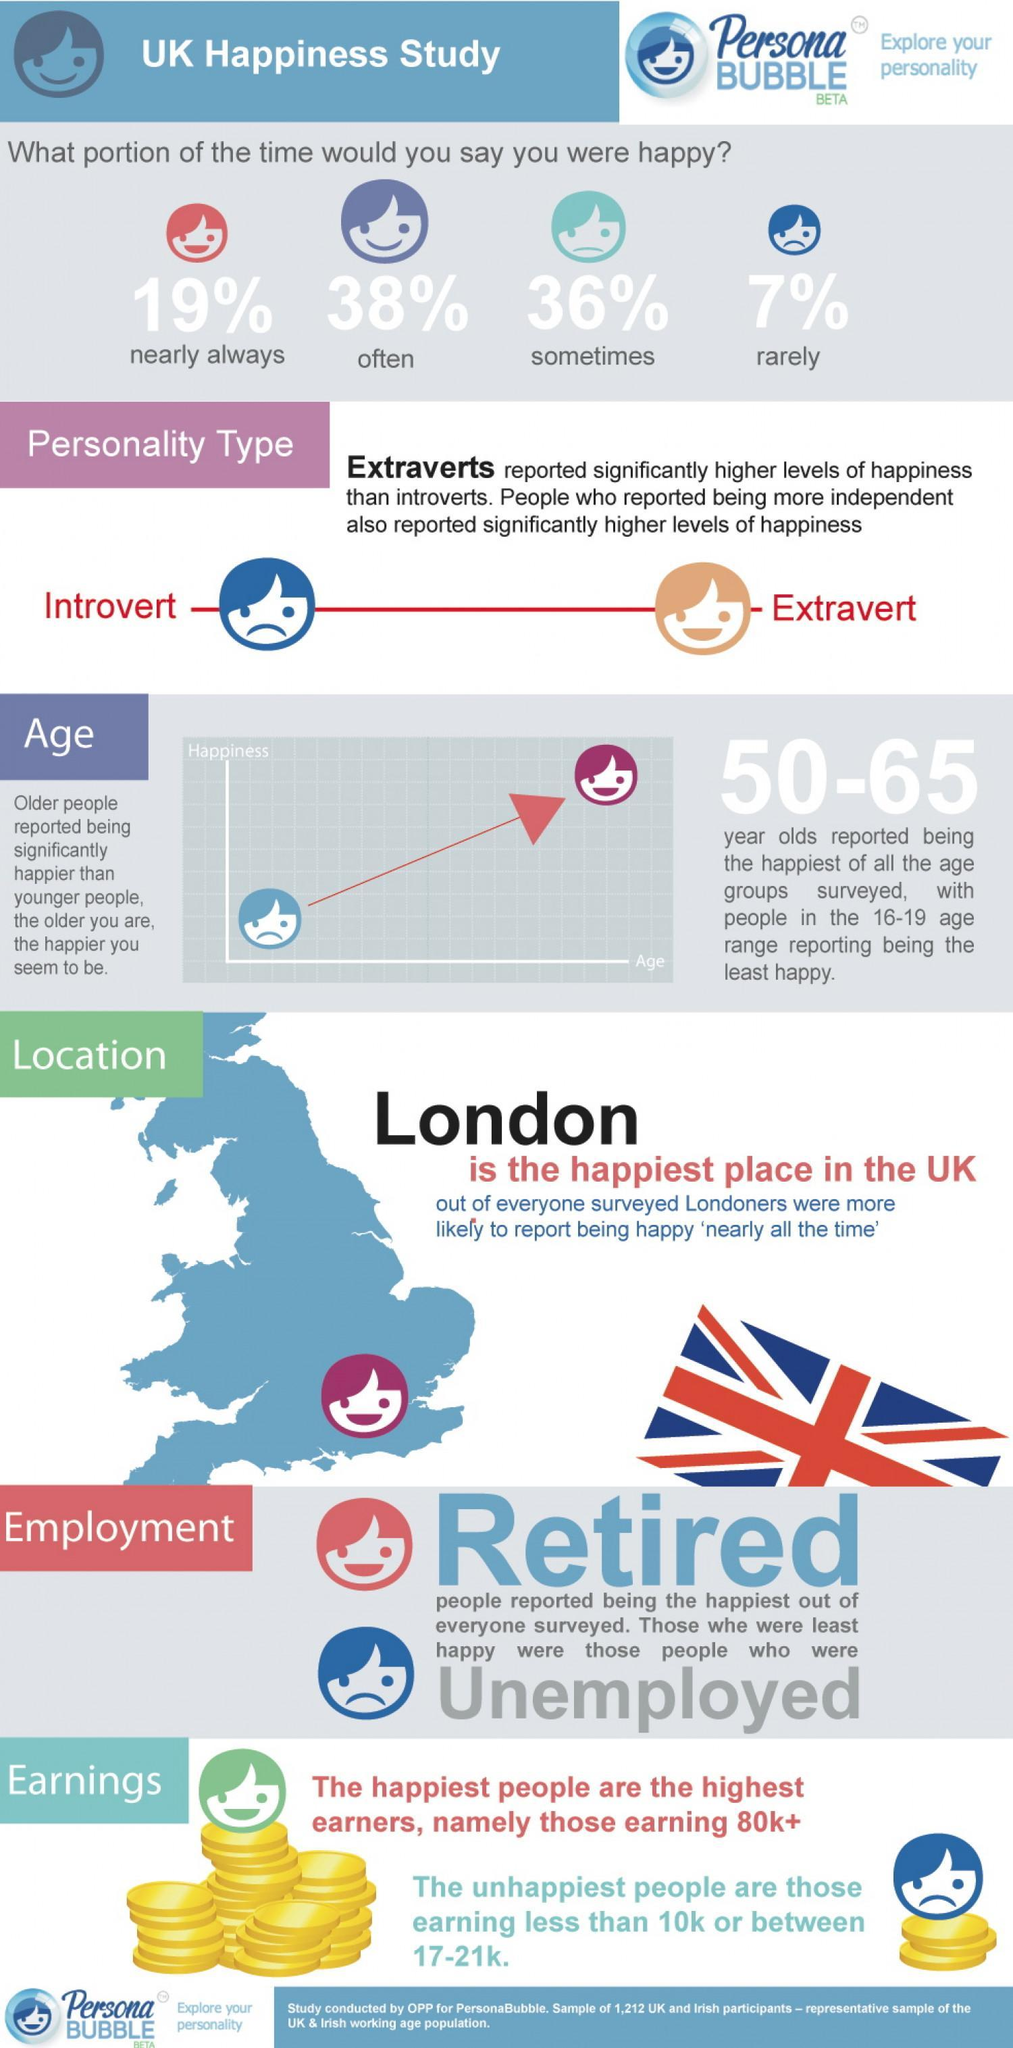as you age, does your happiness increase or decrease
Answer the question with a short phrase. increase Which age group people are the most happiest 50-65 From employment perspective, which category was the least happy unemployed what is the colour of the coins, red or yellow yellow What % believe that they are often or nearly always happy 57 Who is more happy, introvert or extravert? extravert 